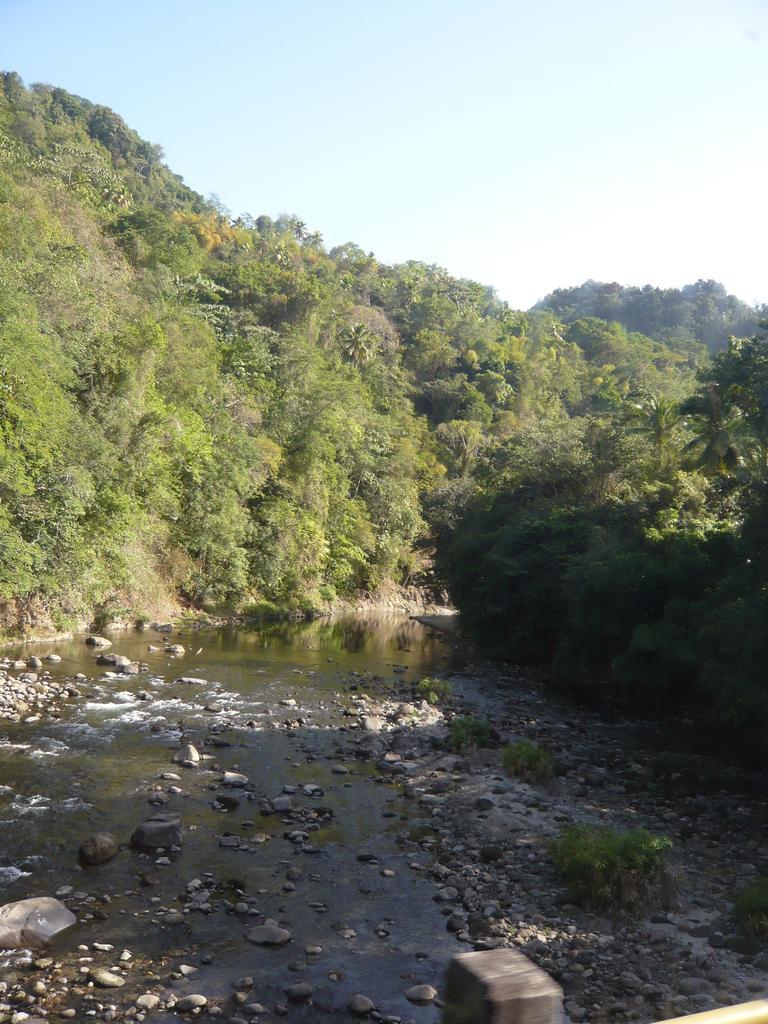Describe this image in one or two sentences. In this image there is water in the middle. In the water there are so many stones. In the background there are trees. At the top there is the sky. 